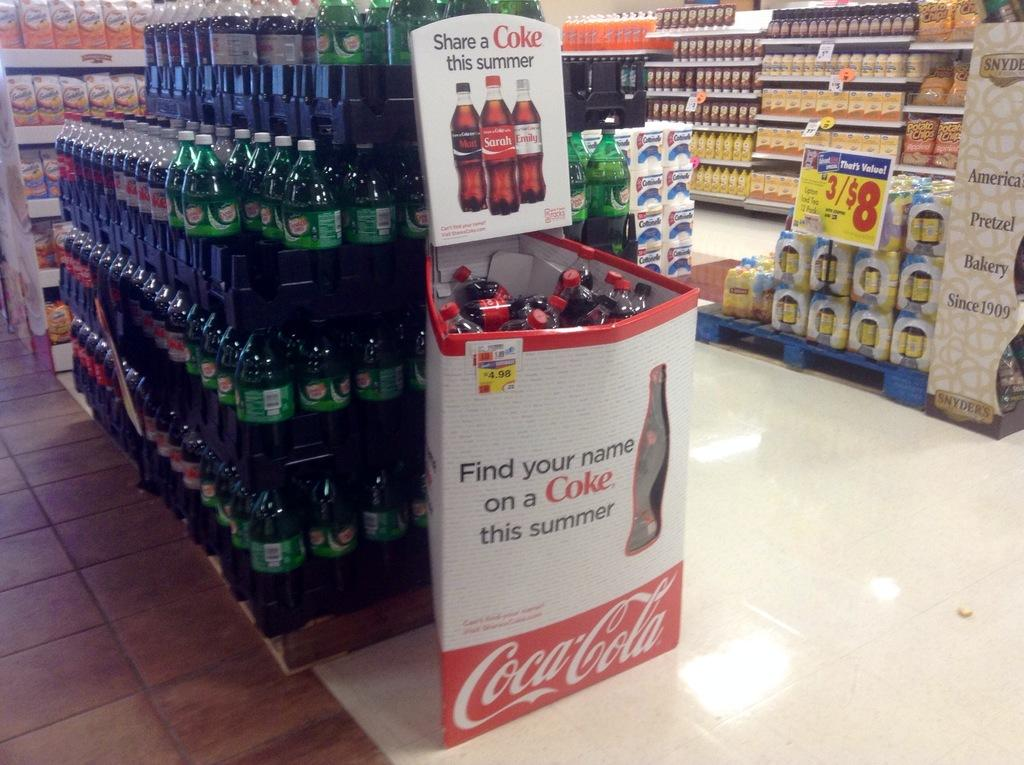<image>
Give a short and clear explanation of the subsequent image. The inside of a store with a Coca-Cola endcap that reads " Find your name on a coke this summer" 